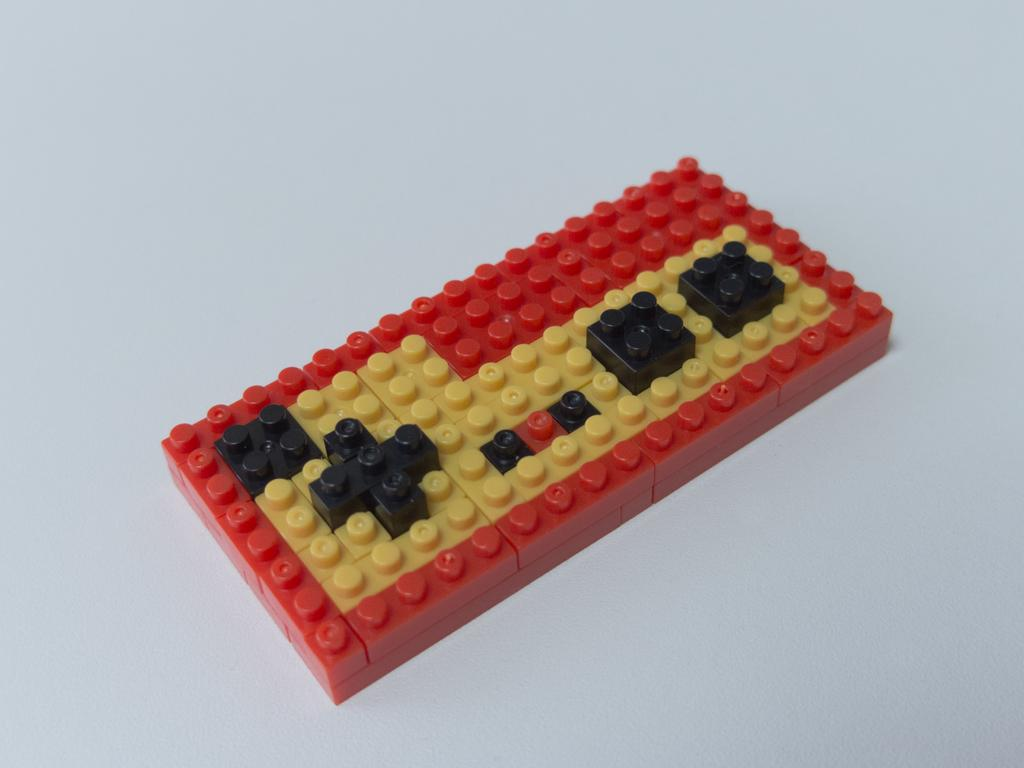What is the main object in the image? There is a lego block in the image. Reasoning: Let's think step by step by step in order to produce the conversation. We start by identifying the main subject in the image, which is the lego block. Since there is only one fact provided, we formulate a question that focuses on the location and characteristics of this subject, ensuring that each question can be answered definitively with the information given. We avoid yes/no questions and ensure that the language is simple and clear. Absurd Question/Answer: What type of cart is being pulled by the lego block in the image? There is no cart present in the image; it only features a lego block. Is there a bridge made of lego blocks in the image? There is no bridge made of lego blocks present in the image; it only features a single lego block. 